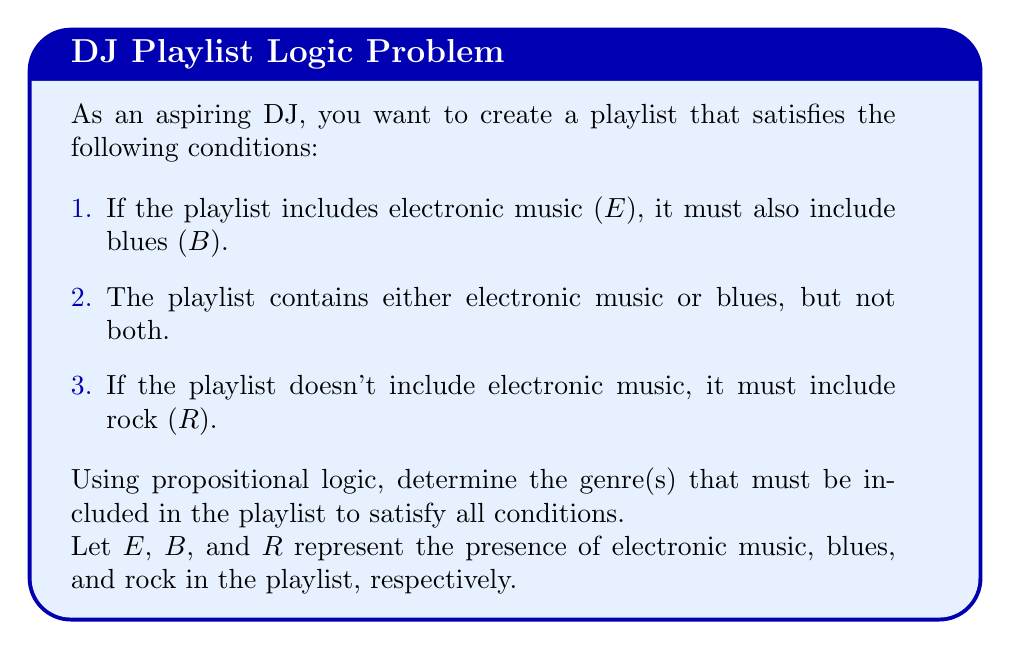Show me your answer to this math problem. Let's approach this step-by-step using propositional logic:

1. Translate the given conditions into logical statements:
   a. $E \rightarrow B$ (If electronic, then blues)
   b. $(E \oplus B)$ (Exclusive OR between electronic and blues)
   c. $\neg E \rightarrow R$ (If not electronic, then rock)

2. From condition (b), we know that either E or B must be true, but not both. Let's consider both cases:

   Case 1: E is true
   - If E is true, then B must be true (from condition a)
   - But this contradicts condition (b)
   - Therefore, E cannot be true

   Case 2: B is true
   - This satisfies condition (b)
   - E must be false (from condition b)
   - If E is false, then R must be true (from condition c)

3. We can conclude that B and R must be true, while E must be false.

4. To verify:
   - $E \rightarrow B$ is satisfied (false implies anything)
   - $(E \oplus B)$ is satisfied (B is true, E is false)
   - $\neg E \rightarrow R$ is satisfied (E is false, R is true)

Therefore, the playlist must include blues and rock, but not electronic music.
Answer: Blues and Rock 